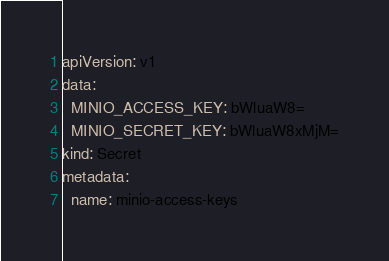Convert code to text. <code><loc_0><loc_0><loc_500><loc_500><_YAML_>apiVersion: v1
data:
  MINIO_ACCESS_KEY: bWluaW8=
  MINIO_SECRET_KEY: bWluaW8xMjM=
kind: Secret
metadata:
  name: minio-access-keys</code> 